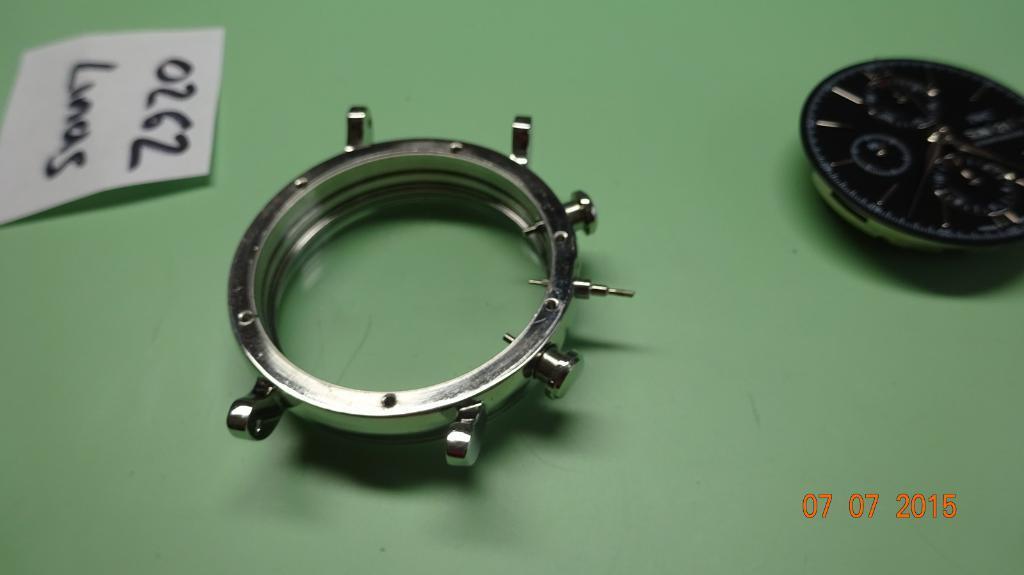In one or two sentences, can you explain what this image depicts? The picture consists of a table, on the table there are parts of the watch. On the left there is a paper, on the paper there is text. In the bottom right corner it is date. 